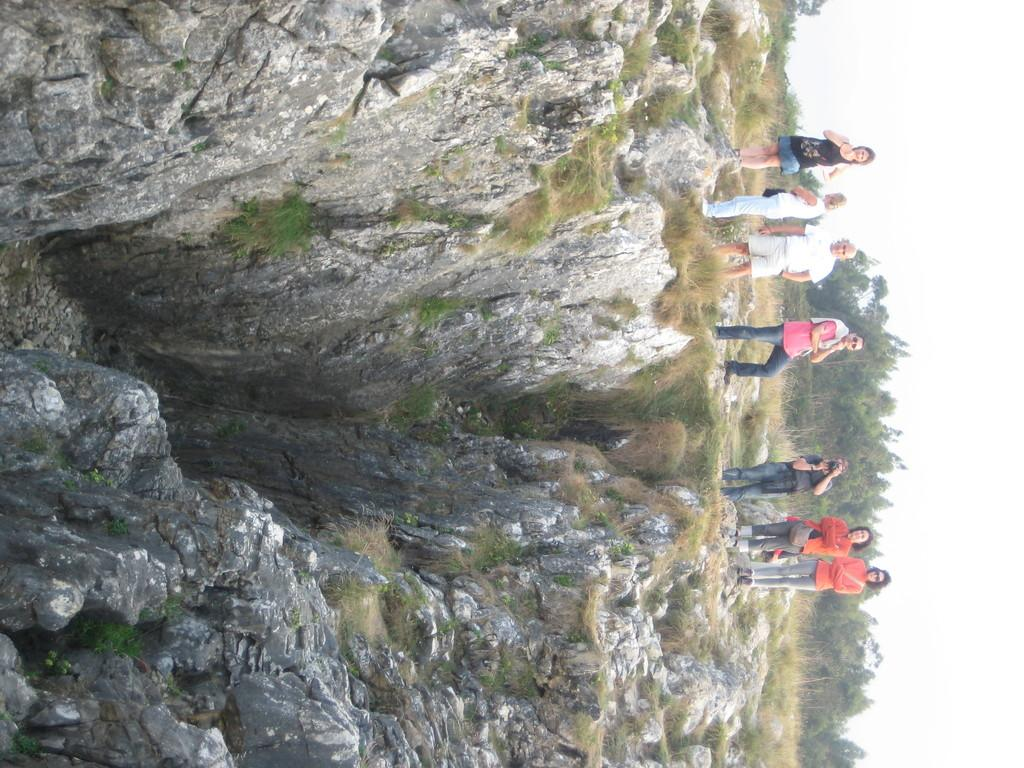What can be seen on the right side of the image? There are people standing on the right side of the image. What is located on the left side of the image? There is a mountain on the left side of the image, and there is also grass on the left side. What type of vegetation is visible in the background of the image? There are trees in the background of the image. What plot of land are the people standing on in the image? There is no specific plot of land mentioned in the image, as it only shows people standing on the right side and a mountain on the left side. How many hands are visible in the image? There is no mention of hands in the image, as it focuses on people standing, a mountain, grass, and trees. 